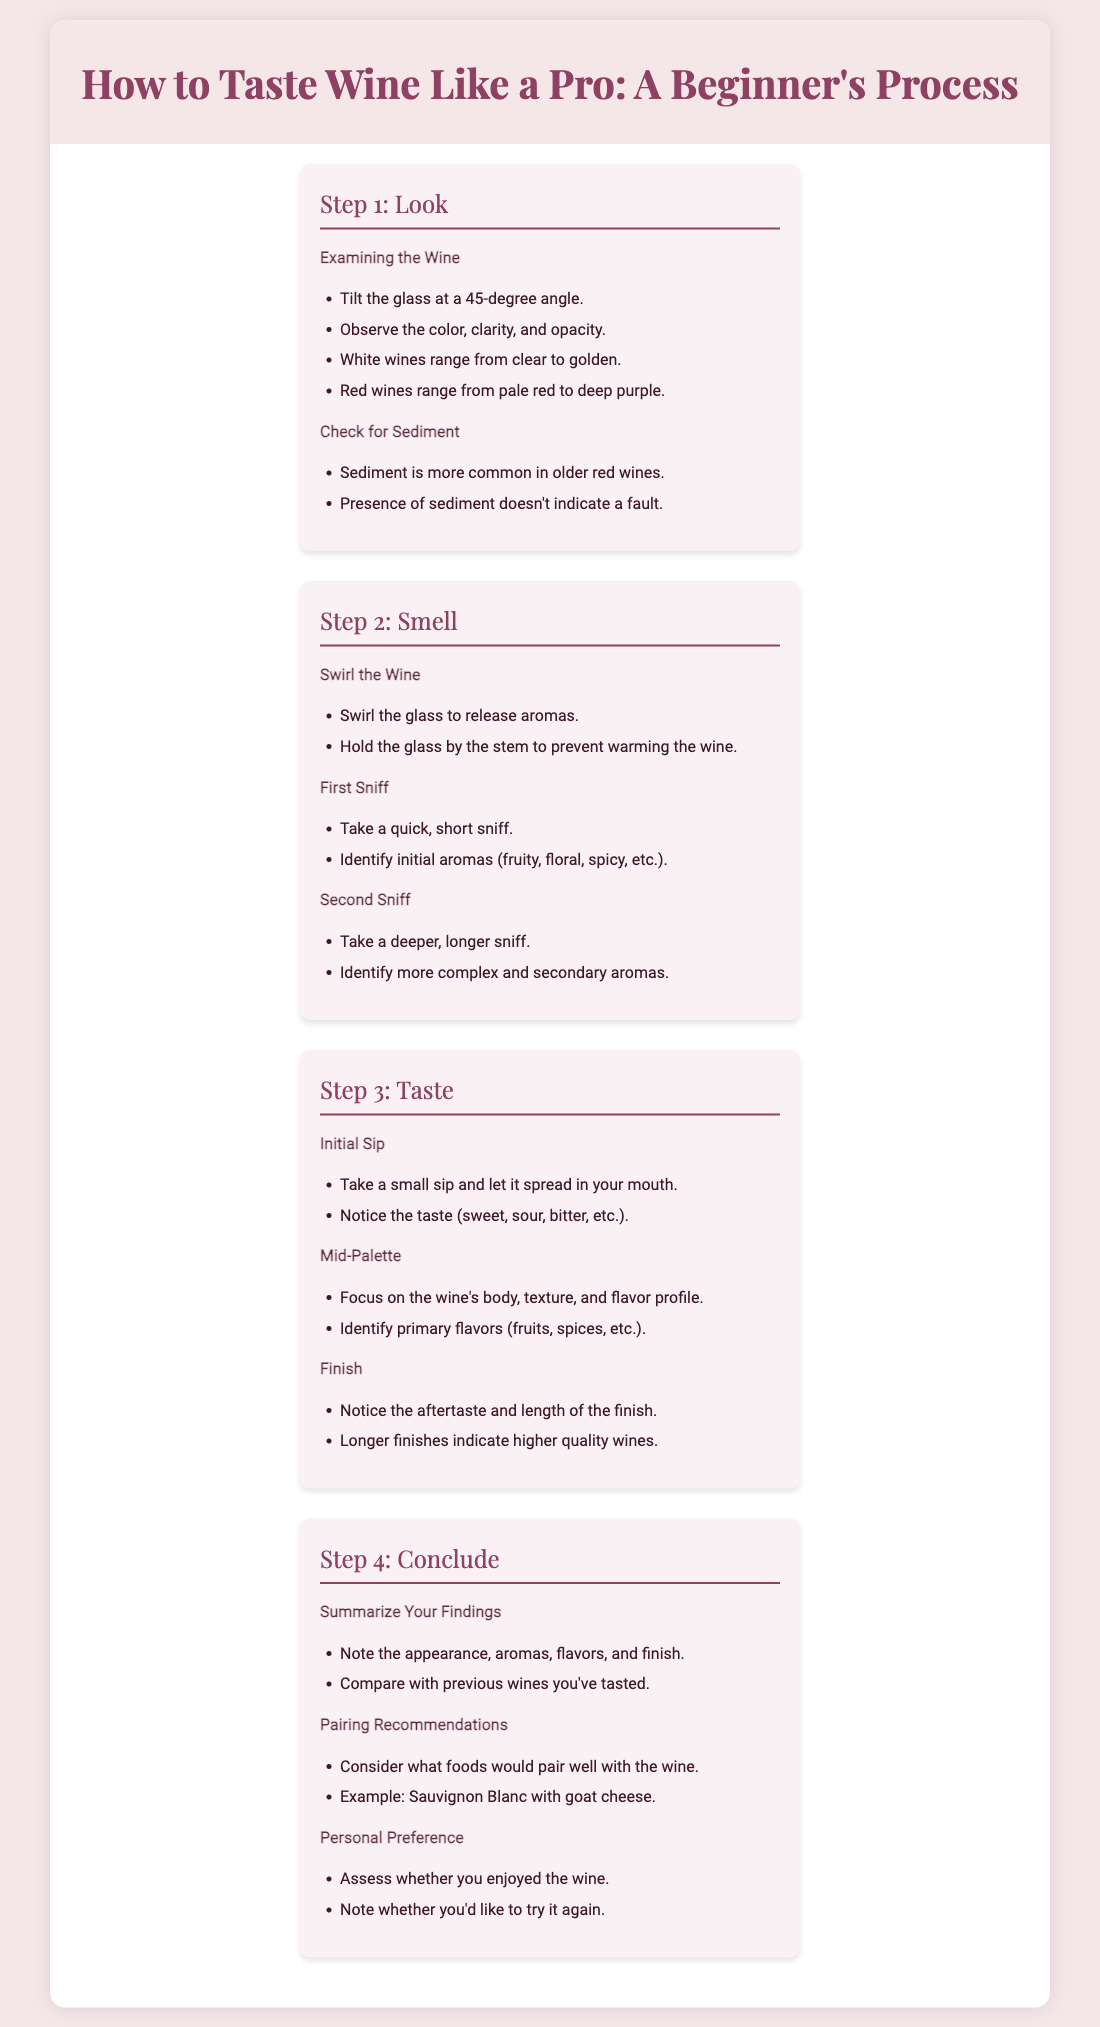What is the title of the infographic? The title is prominently displayed at the top of the document, indicating the subject matter.
Answer: How to Taste Wine Like a Pro: A Beginner's Process What is the first step of the wine tasting process? The first step is outlined in detail, describing the initial action when tasting wine.
Answer: Look What should you observe in the wine during the first step? The step provides a list of specific things to observe when examining the wine.
Answer: Color, clarity, and opacity What are the primary flavors to focus on during the mid-palate? The step provides guidance on identifying specific flavors while tasting.
Answer: Fruits, spices What should you do in the concluding step regarding personal preference? The conclusion advises on evaluating your enjoyment of the wine.
Answer: Assess whether you enjoyed the wine How is sediment characterized in older red wines? The details note a specific feature regarding older red wines and sediment presence.
Answer: More common What is recommended to pair with Sauvignon Blanc? The document provides an example of food pairing with a specific wine type.
Answer: Goat cheese What action is recommended before the first sniff? The step describes a specific action to enhance the smelling experience of the wine.
Answer: Swirl the glass What does a longer finish typically indicate about a wine's quality? The section explains implications of the finish length relating to quality.
Answer: Higher quality wines 